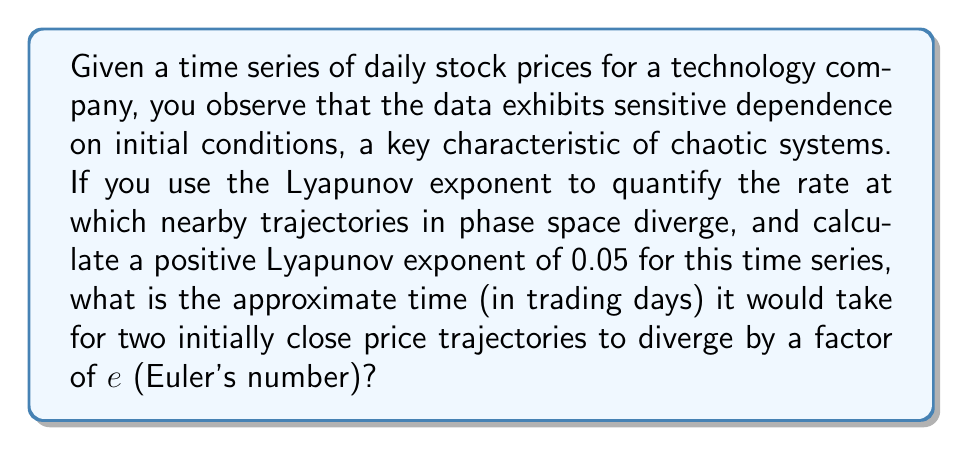Could you help me with this problem? To solve this problem, we'll use the properties of the Lyapunov exponent in chaotic systems:

1) The Lyapunov exponent ($\lambda$) measures the rate of separation of infinitesimally close trajectories. In this case, $\lambda = 0.05$.

2) The divergence of trajectories in a chaotic system is exponential and can be described by the equation:

   $$d(t) = d_0 e^{\lambda t}$$

   where $d(t)$ is the separation at time $t$, $d_0$ is the initial separation, and $\lambda$ is the Lyapunov exponent.

3) We want to find the time $t$ when the divergence reaches a factor of $e$. This means:

   $$\frac{d(t)}{d_0} = e$$

4) Substituting this into our equation:

   $$e = e^{\lambda t}$$

5) Taking the natural logarithm of both sides:

   $$\ln(e) = \lambda t$$

6) Simplify, knowing that $\ln(e) = 1$:

   $$1 = \lambda t$$

7) Solve for $t$:

   $$t = \frac{1}{\lambda} = \frac{1}{0.05} = 20$$

Therefore, it would take approximately 20 trading days for two initially close price trajectories to diverge by a factor of $e$.
Answer: 20 trading days 